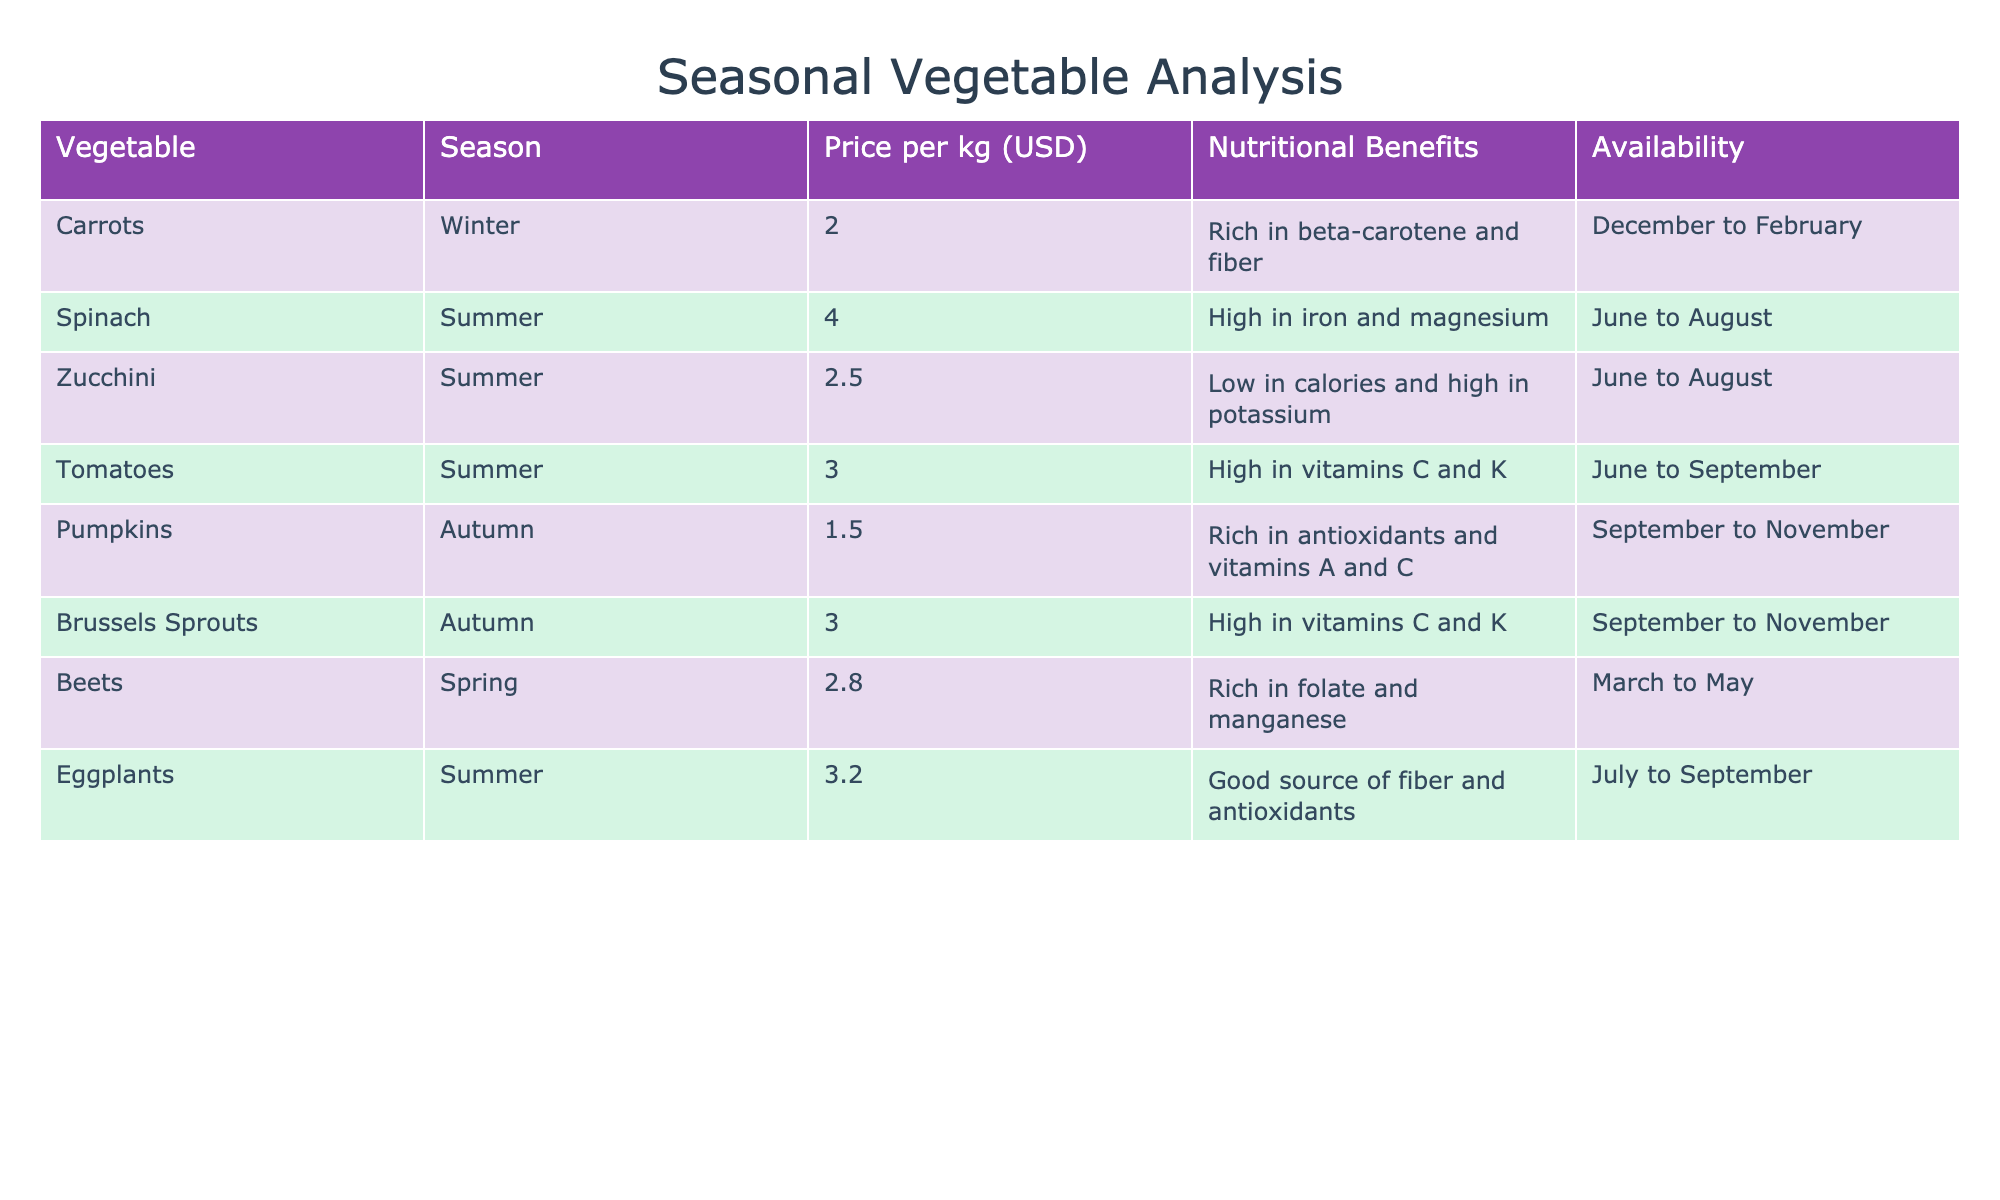What is the price per kg of carrots? The table lists carrots under the Winter season, and the corresponding price per kg is provided in the Price per kg column. According to the table, carrots are priced at 2.00 USD per kg.
Answer: 2.00 USD Which vegetable has the highest nutritional benefits? The table includes a column for Nutritional Benefits, but it's subjective to determine the "highest" benefit as different vegetables offer unique nutrients. However, one could note that spinach is high in iron and magnesium, and both tomatoes and Brussels sprouts are high in vitamins C and K, making it a bit challenging to establish a single "highest" vegetable based on the textual information.
Answer: Subjective, depends on the criteria used How many vegetables are available in summer? The table specifies the availability of vegetables per season. By counting the vegetables listed under the Summer season (Spinach, Zucchini, Tomatoes, Eggplants), we find there are a total of 4 vegetables available in Summer.
Answer: 4 What is the average price of vegetables in autumn? To find the average price, first identify the vegetables available in autumn: Pumpkins (1.50 USD) and Brussels Sprouts (3.00 USD). Add these prices together: 1.50 + 3.00 = 4.50 USD. Then divide by the number of vegetables (2): 4.50 / 2 = 2.25 USD. This gives us the average price.
Answer: 2.25 USD Are beets available in autumn? By checking the Availability column for beets, we see they are listed for Spring (March to May), which means they are not available in Autumn. Therefore, the answer is no.
Answer: No Which season has the cheapest vegetable, and what is the price? Looking at the Price per kg column, we find the cheapest vegetable is Pumpkins, priced at 1.50 USD. Pumpkins are available in Autumn.
Answer: Autumn, 1.50 USD What vegetable is available from June to August, and what is its price? From the table, Spinach, Zucchini, and Tomatoes are available in that timeframe. The prices are 4.00 USD for Spinach, 2.50 USD for Zucchini, and 3.00 USD for Tomatoes.
Answer: Spinach (4.00 USD), Zucchini (2.50 USD), Tomatoes (3.00 USD) Is spinach the only vegetable available in summer? By examining the Availability column, we can see multiple vegetables are available during Summer: Spinach, Zucchini, Tomatoes, and Eggplants. Thus, spinach is not the only vegetable available in that season.
Answer: No 